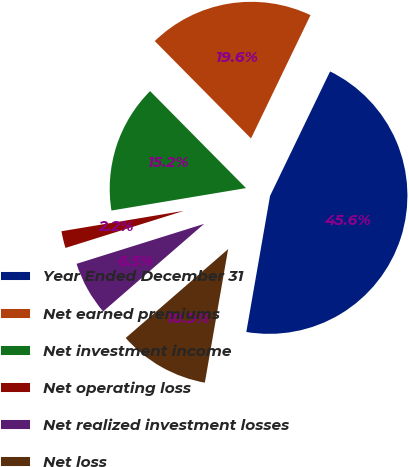Convert chart to OTSL. <chart><loc_0><loc_0><loc_500><loc_500><pie_chart><fcel>Year Ended December 31<fcel>Net earned premiums<fcel>Net investment income<fcel>Net operating loss<fcel>Net realized investment losses<fcel>Net loss<nl><fcel>45.59%<fcel>19.56%<fcel>15.22%<fcel>2.2%<fcel>6.54%<fcel>10.88%<nl></chart> 